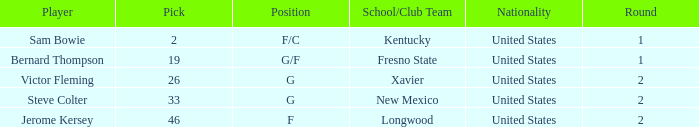What is the highest Pick, when Position is "G/F"? 19.0. 